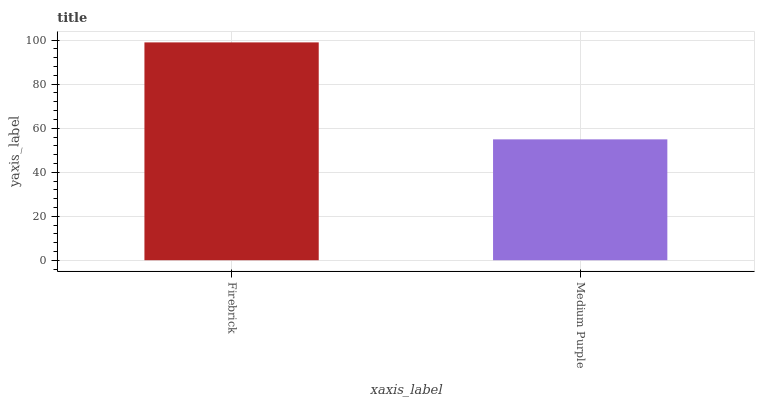Is Medium Purple the minimum?
Answer yes or no. Yes. Is Firebrick the maximum?
Answer yes or no. Yes. Is Medium Purple the maximum?
Answer yes or no. No. Is Firebrick greater than Medium Purple?
Answer yes or no. Yes. Is Medium Purple less than Firebrick?
Answer yes or no. Yes. Is Medium Purple greater than Firebrick?
Answer yes or no. No. Is Firebrick less than Medium Purple?
Answer yes or no. No. Is Firebrick the high median?
Answer yes or no. Yes. Is Medium Purple the low median?
Answer yes or no. Yes. Is Medium Purple the high median?
Answer yes or no. No. Is Firebrick the low median?
Answer yes or no. No. 